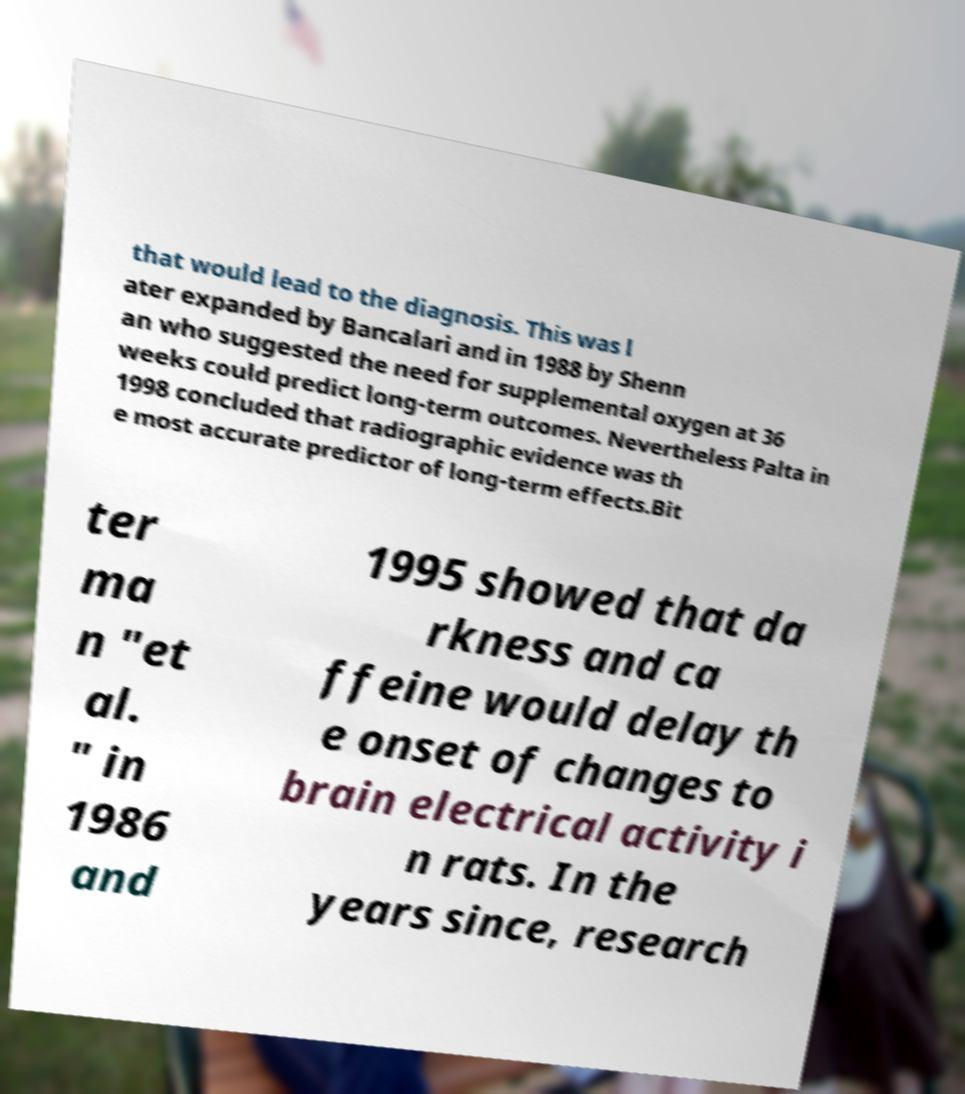Can you read and provide the text displayed in the image?This photo seems to have some interesting text. Can you extract and type it out for me? that would lead to the diagnosis. This was l ater expanded by Bancalari and in 1988 by Shenn an who suggested the need for supplemental oxygen at 36 weeks could predict long-term outcomes. Nevertheless Palta in 1998 concluded that radiographic evidence was th e most accurate predictor of long-term effects.Bit ter ma n "et al. " in 1986 and 1995 showed that da rkness and ca ffeine would delay th e onset of changes to brain electrical activity i n rats. In the years since, research 